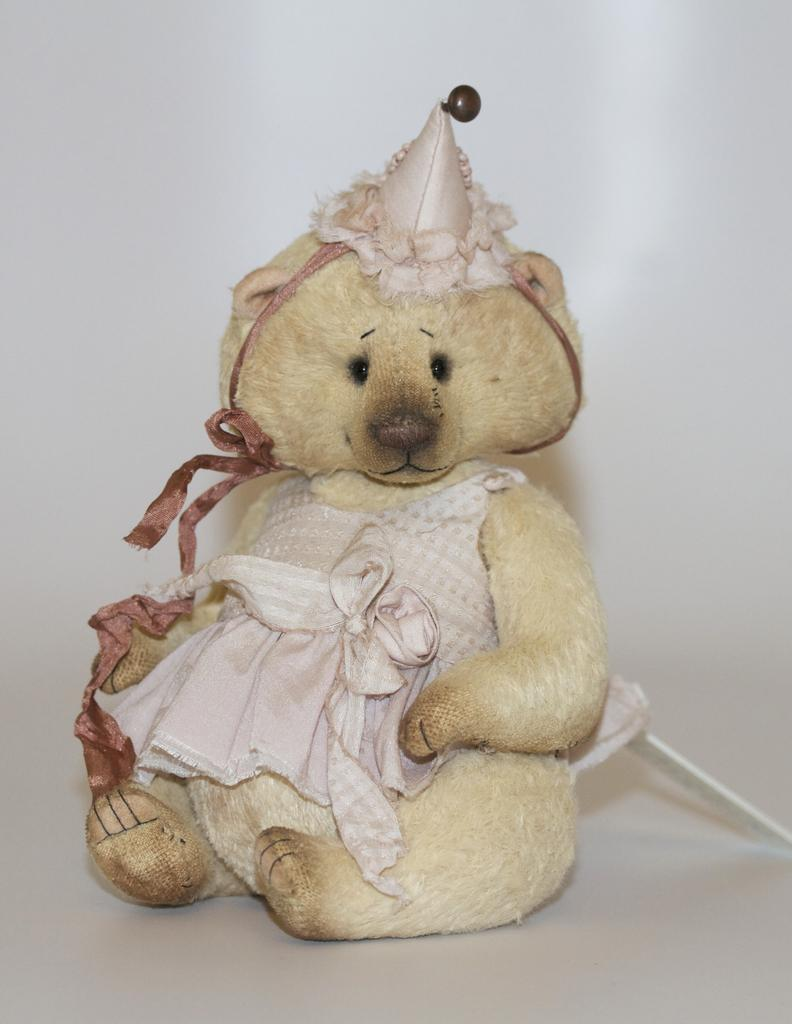What is the main subject of the picture? The main highlight of the picture is a doll. What color dominates the background of the picture? The remaining portion of the picture is in white color. Can you see any beef in the picture? There is no beef present in the image. Is there a snake visible in the picture? There is no snake present in the image. 